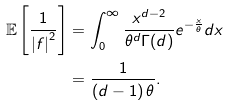Convert formula to latex. <formula><loc_0><loc_0><loc_500><loc_500>\mathbb { E } \left [ \frac { 1 } { \left | f \right | ^ { 2 } } \right ] & = \int _ { 0 } ^ { \infty } \frac { x ^ { d - 2 } } { \theta ^ { d } \Gamma ( d ) } e ^ { - \frac { x } { \theta } } d x \\ & = \frac { 1 } { \left ( d - 1 \right ) \theta } .</formula> 